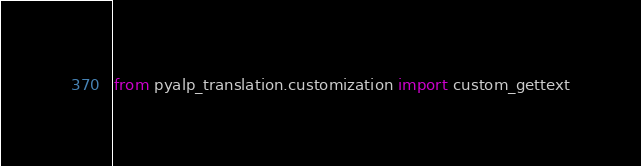<code> <loc_0><loc_0><loc_500><loc_500><_Python_>from pyalp_translation.customization import custom_gettext
</code> 